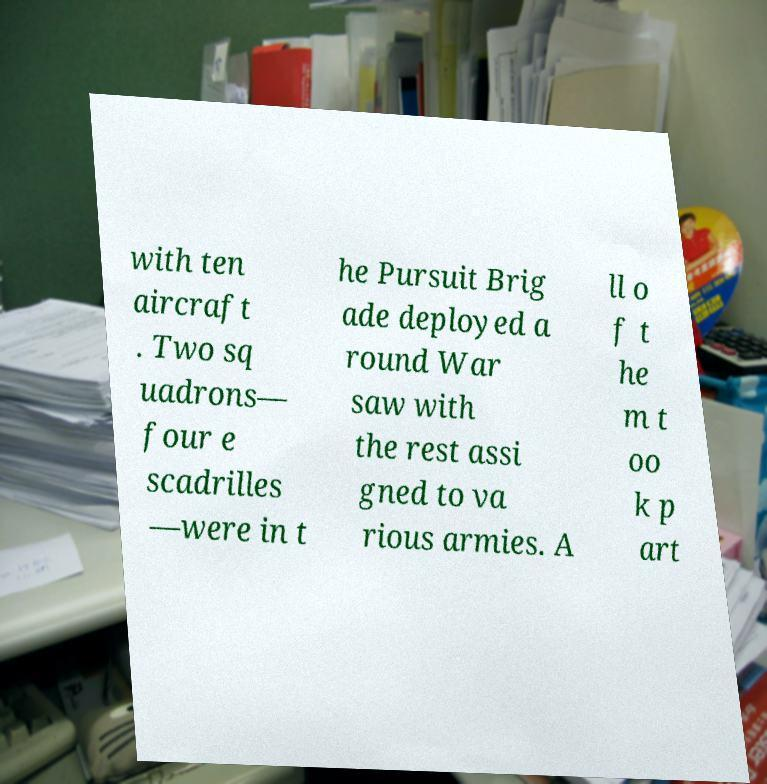Please identify and transcribe the text found in this image. with ten aircraft . Two sq uadrons— four e scadrilles —were in t he Pursuit Brig ade deployed a round War saw with the rest assi gned to va rious armies. A ll o f t he m t oo k p art 